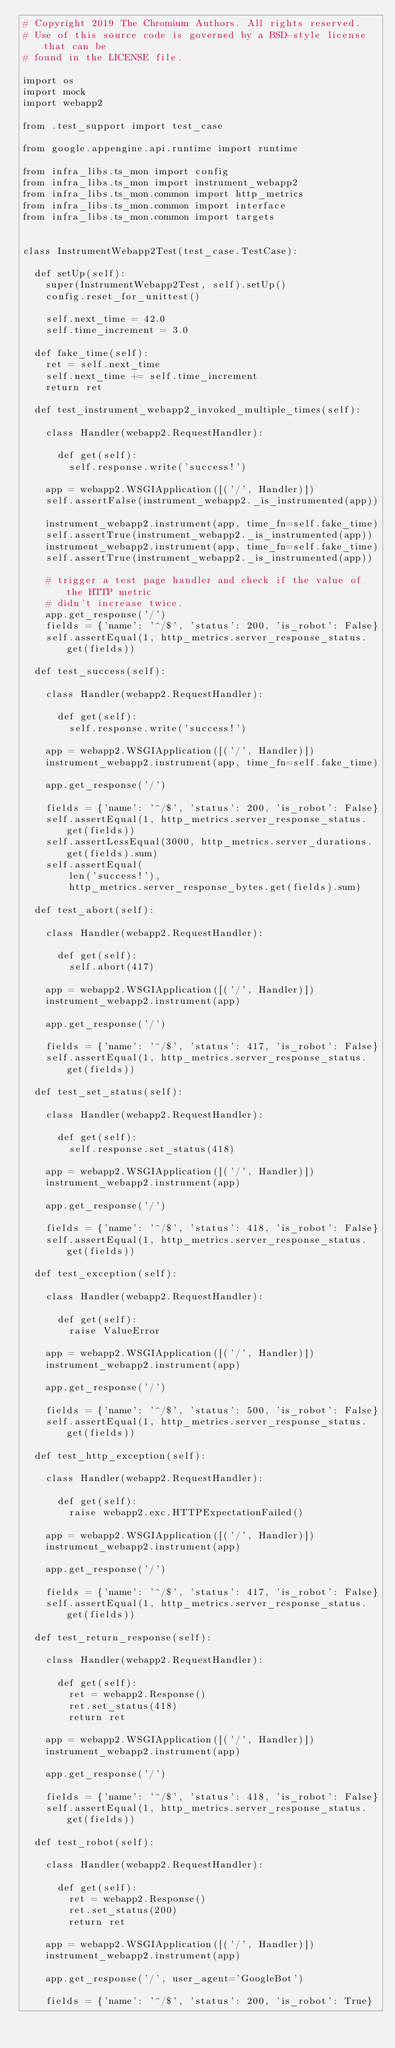<code> <loc_0><loc_0><loc_500><loc_500><_Python_># Copyright 2019 The Chromium Authors. All rights reserved.
# Use of this source code is governed by a BSD-style license that can be
# found in the LICENSE file.

import os
import mock
import webapp2

from .test_support import test_case

from google.appengine.api.runtime import runtime

from infra_libs.ts_mon import config
from infra_libs.ts_mon import instrument_webapp2
from infra_libs.ts_mon.common import http_metrics
from infra_libs.ts_mon.common import interface
from infra_libs.ts_mon.common import targets


class InstrumentWebapp2Test(test_case.TestCase):

  def setUp(self):
    super(InstrumentWebapp2Test, self).setUp()
    config.reset_for_unittest()

    self.next_time = 42.0
    self.time_increment = 3.0

  def fake_time(self):
    ret = self.next_time
    self.next_time += self.time_increment
    return ret

  def test_instrument_webapp2_invoked_multiple_times(self):

    class Handler(webapp2.RequestHandler):

      def get(self):
        self.response.write('success!')

    app = webapp2.WSGIApplication([('/', Handler)])
    self.assertFalse(instrument_webapp2._is_instrumented(app))

    instrument_webapp2.instrument(app, time_fn=self.fake_time)
    self.assertTrue(instrument_webapp2._is_instrumented(app))
    instrument_webapp2.instrument(app, time_fn=self.fake_time)
    self.assertTrue(instrument_webapp2._is_instrumented(app))

    # trigger a test page handler and check if the value of the HTTP metric
    # didn't increase twice.
    app.get_response('/')
    fields = {'name': '^/$', 'status': 200, 'is_robot': False}
    self.assertEqual(1, http_metrics.server_response_status.get(fields))

  def test_success(self):

    class Handler(webapp2.RequestHandler):

      def get(self):
        self.response.write('success!')

    app = webapp2.WSGIApplication([('/', Handler)])
    instrument_webapp2.instrument(app, time_fn=self.fake_time)

    app.get_response('/')

    fields = {'name': '^/$', 'status': 200, 'is_robot': False}
    self.assertEqual(1, http_metrics.server_response_status.get(fields))
    self.assertLessEqual(3000, http_metrics.server_durations.get(fields).sum)
    self.assertEqual(
        len('success!'),
        http_metrics.server_response_bytes.get(fields).sum)

  def test_abort(self):

    class Handler(webapp2.RequestHandler):

      def get(self):
        self.abort(417)

    app = webapp2.WSGIApplication([('/', Handler)])
    instrument_webapp2.instrument(app)

    app.get_response('/')

    fields = {'name': '^/$', 'status': 417, 'is_robot': False}
    self.assertEqual(1, http_metrics.server_response_status.get(fields))

  def test_set_status(self):

    class Handler(webapp2.RequestHandler):

      def get(self):
        self.response.set_status(418)

    app = webapp2.WSGIApplication([('/', Handler)])
    instrument_webapp2.instrument(app)

    app.get_response('/')

    fields = {'name': '^/$', 'status': 418, 'is_robot': False}
    self.assertEqual(1, http_metrics.server_response_status.get(fields))

  def test_exception(self):

    class Handler(webapp2.RequestHandler):

      def get(self):
        raise ValueError

    app = webapp2.WSGIApplication([('/', Handler)])
    instrument_webapp2.instrument(app)

    app.get_response('/')

    fields = {'name': '^/$', 'status': 500, 'is_robot': False}
    self.assertEqual(1, http_metrics.server_response_status.get(fields))

  def test_http_exception(self):

    class Handler(webapp2.RequestHandler):

      def get(self):
        raise webapp2.exc.HTTPExpectationFailed()

    app = webapp2.WSGIApplication([('/', Handler)])
    instrument_webapp2.instrument(app)

    app.get_response('/')

    fields = {'name': '^/$', 'status': 417, 'is_robot': False}
    self.assertEqual(1, http_metrics.server_response_status.get(fields))

  def test_return_response(self):

    class Handler(webapp2.RequestHandler):

      def get(self):
        ret = webapp2.Response()
        ret.set_status(418)
        return ret

    app = webapp2.WSGIApplication([('/', Handler)])
    instrument_webapp2.instrument(app)

    app.get_response('/')

    fields = {'name': '^/$', 'status': 418, 'is_robot': False}
    self.assertEqual(1, http_metrics.server_response_status.get(fields))

  def test_robot(self):

    class Handler(webapp2.RequestHandler):

      def get(self):
        ret = webapp2.Response()
        ret.set_status(200)
        return ret

    app = webapp2.WSGIApplication([('/', Handler)])
    instrument_webapp2.instrument(app)

    app.get_response('/', user_agent='GoogleBot')

    fields = {'name': '^/$', 'status': 200, 'is_robot': True}</code> 